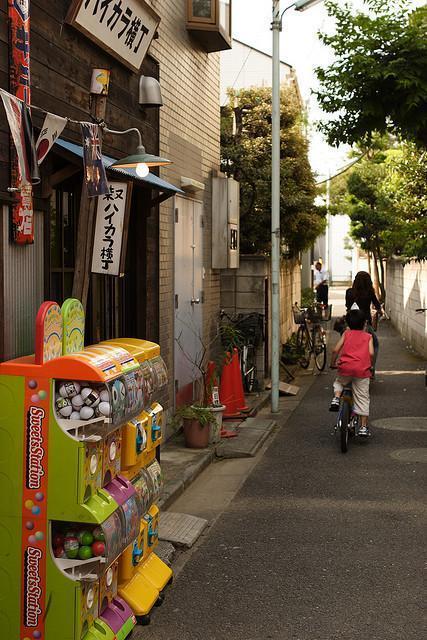How many cars aare parked next to the pile of garbage bags?
Give a very brief answer. 0. 